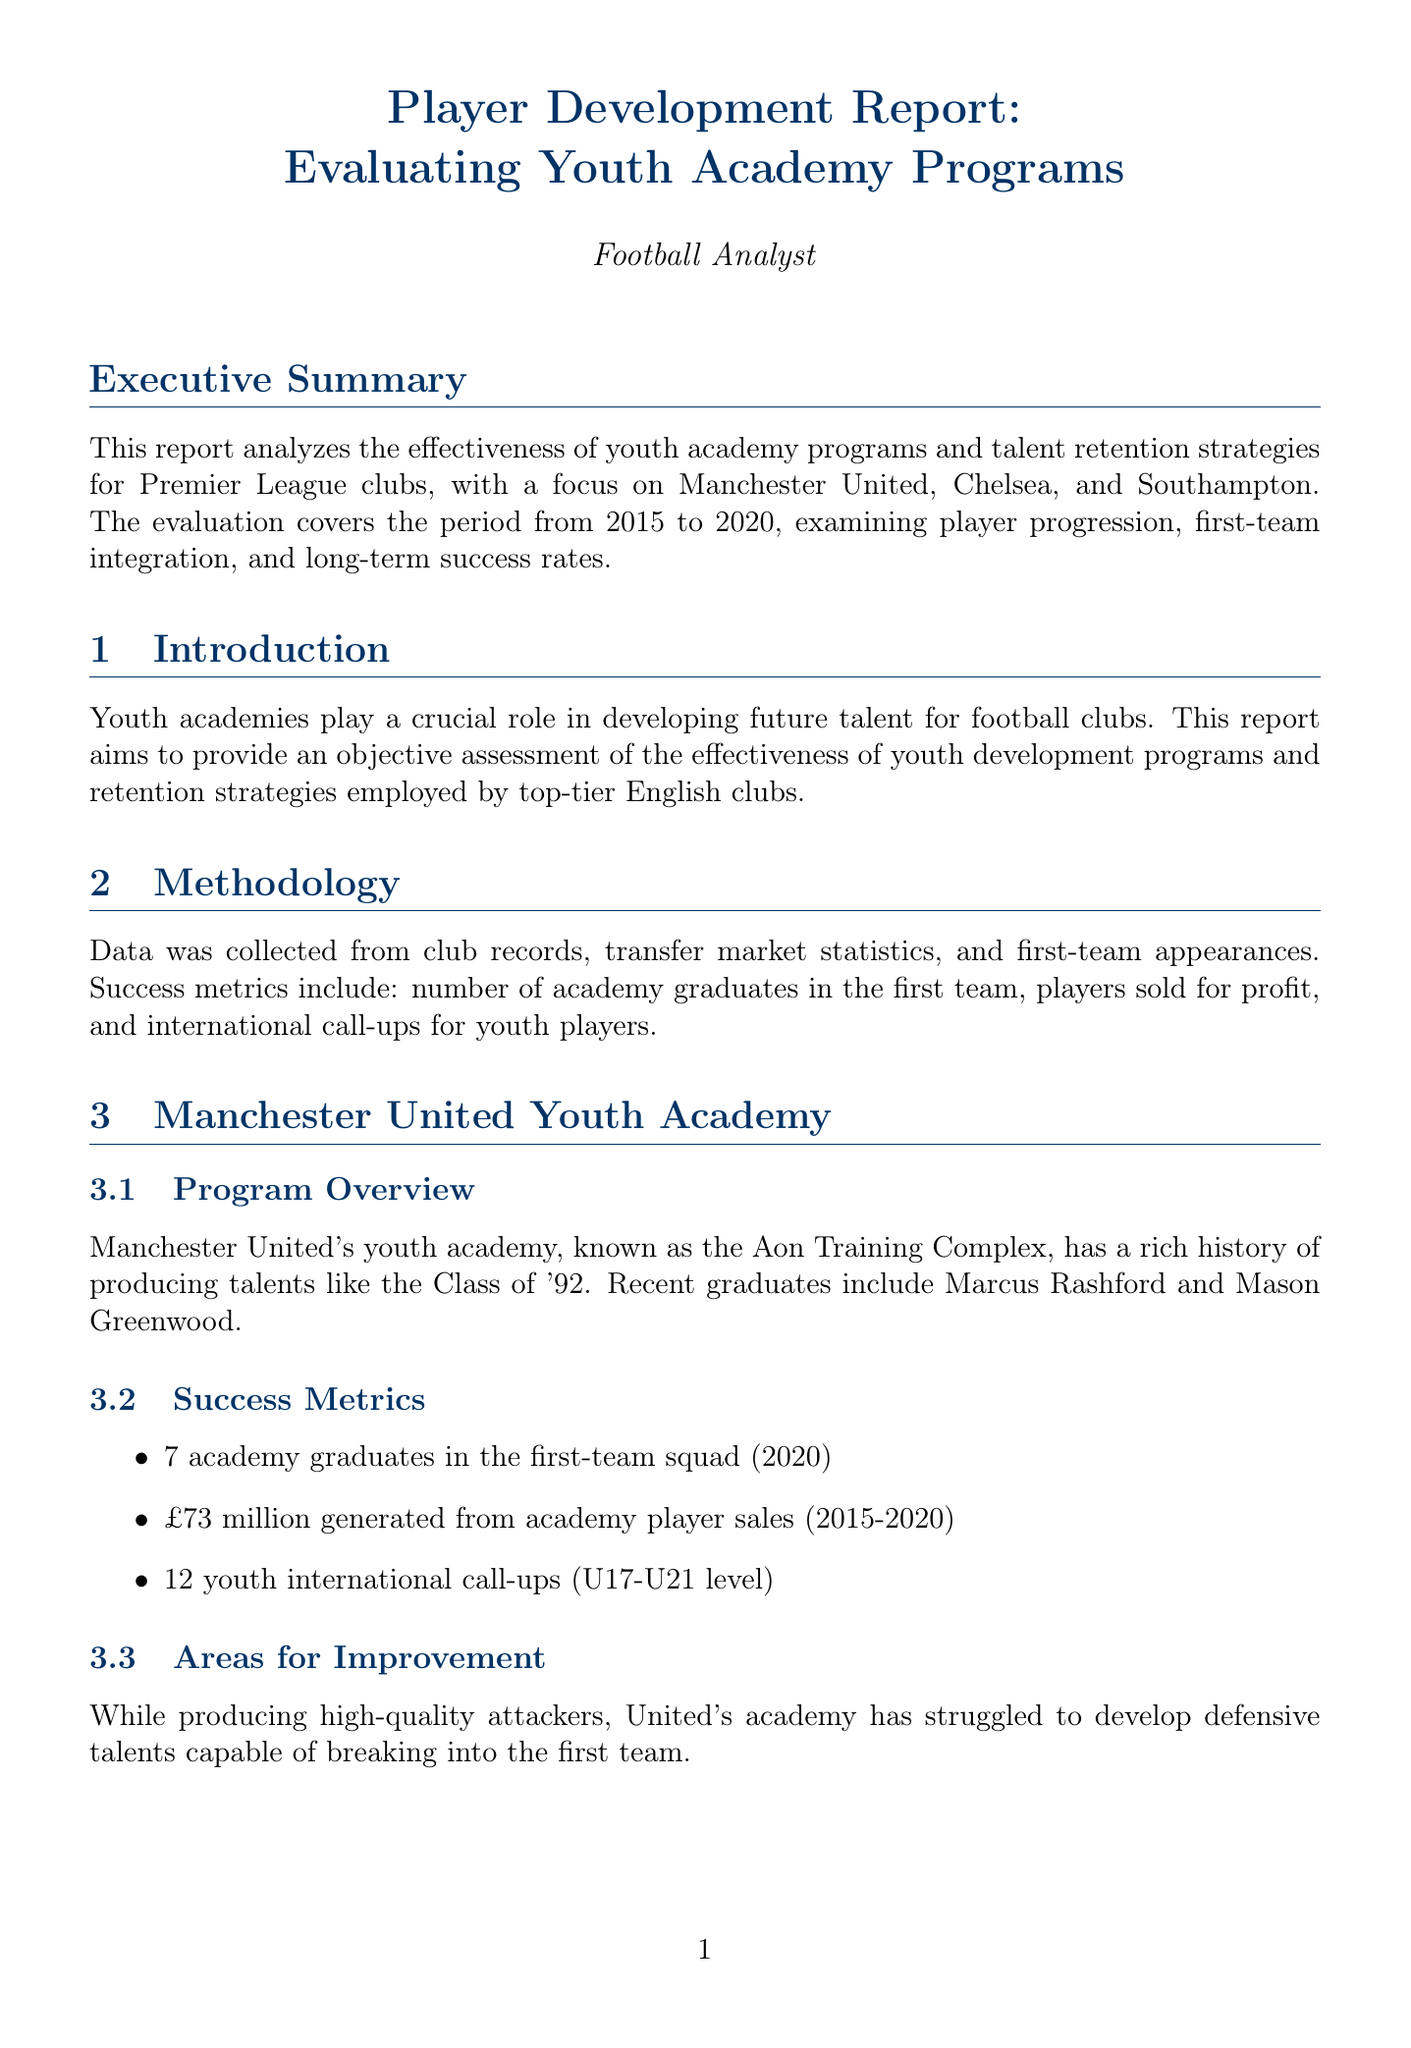What clubs are evaluated in the report? The report specifically evaluates three clubs: Manchester United, Chelsea, and Southampton.
Answer: Manchester United, Chelsea, Southampton How many academy graduates were in Manchester United's first-team squad in 2020? The document states that there were 7 academy graduates in Manchester United's first-team squad in 2020.
Answer: 7 What is the total profit generated from Southampton's academy player sales from 2015 to 2020? The document mentions that Southampton generated £152 million from academy player sales during the specified time frame.
Answer: £152 million What improvement is noted in Chelsea's youth academy? The report highlights recent policy changes leading to increased opportunities for academy graduates like Mason Mount and Tammy Abraham.
Answer: Increased opportunities What is a common strategy for talent retention mentioned in the report? The document lists offering competitive salaries to youth prospects as one of the common strategies employed by clubs.
Answer: Competitive salaries Which club leads in first-team integration according to the comparative analysis? The analysis indicates that Manchester United leads in first-team integration among the evaluated clubs.
Answer: Manchester United What is one area for improvement identified for Manchester United’s youth academy? The document states that Manchester United's academy has struggled to develop defensive talents capable of breaking into the first team.
Answer: Developing defensive talents What is a key strength of Southampton's youth academy? The report notes Southampton's ability to provide clear pathways to first-team football as a key strength.
Answer: Clear pathways to first-team football What does the recommendation suggest clubs should focus on? The report's recommendations emphasize that clubs should focus on creating clear pathways to first-team football.
Answer: Creating clear pathways to first-team football 